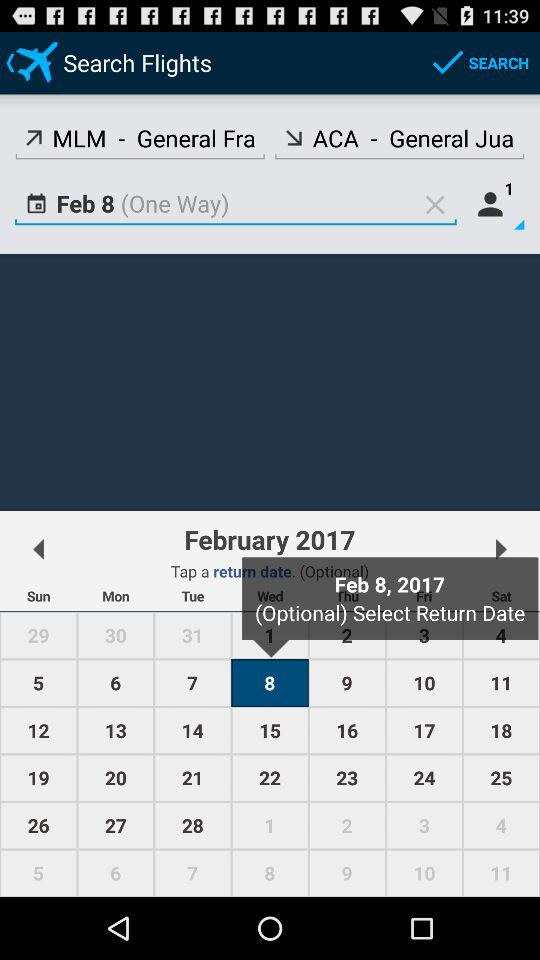What date is selected? The selected date is Wednesday, February 8, 2017. 